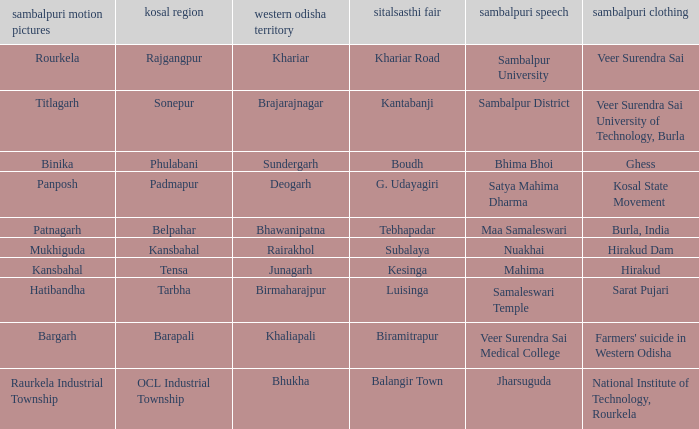What is the sitalsasthi carnival with hirakud as sambalpuri saree? Kesinga. 